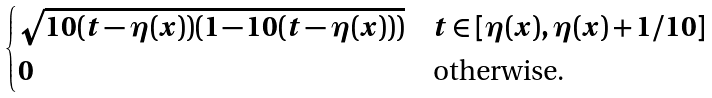Convert formula to latex. <formula><loc_0><loc_0><loc_500><loc_500>\begin{cases} \sqrt { 1 0 ( t - \eta ( x ) ) ( 1 - 1 0 ( t - \eta ( x ) ) ) } & t \in [ \eta ( x ) , \eta ( x ) + 1 / 1 0 ] \\ 0 & \text {otherwise.} \end{cases}</formula> 